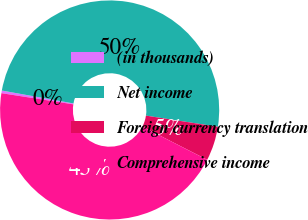<chart> <loc_0><loc_0><loc_500><loc_500><pie_chart><fcel>(in thousands)<fcel>Net income<fcel>Foreign currency translation<fcel>Comprehensive income<nl><fcel>0.39%<fcel>49.61%<fcel>5.06%<fcel>44.94%<nl></chart> 